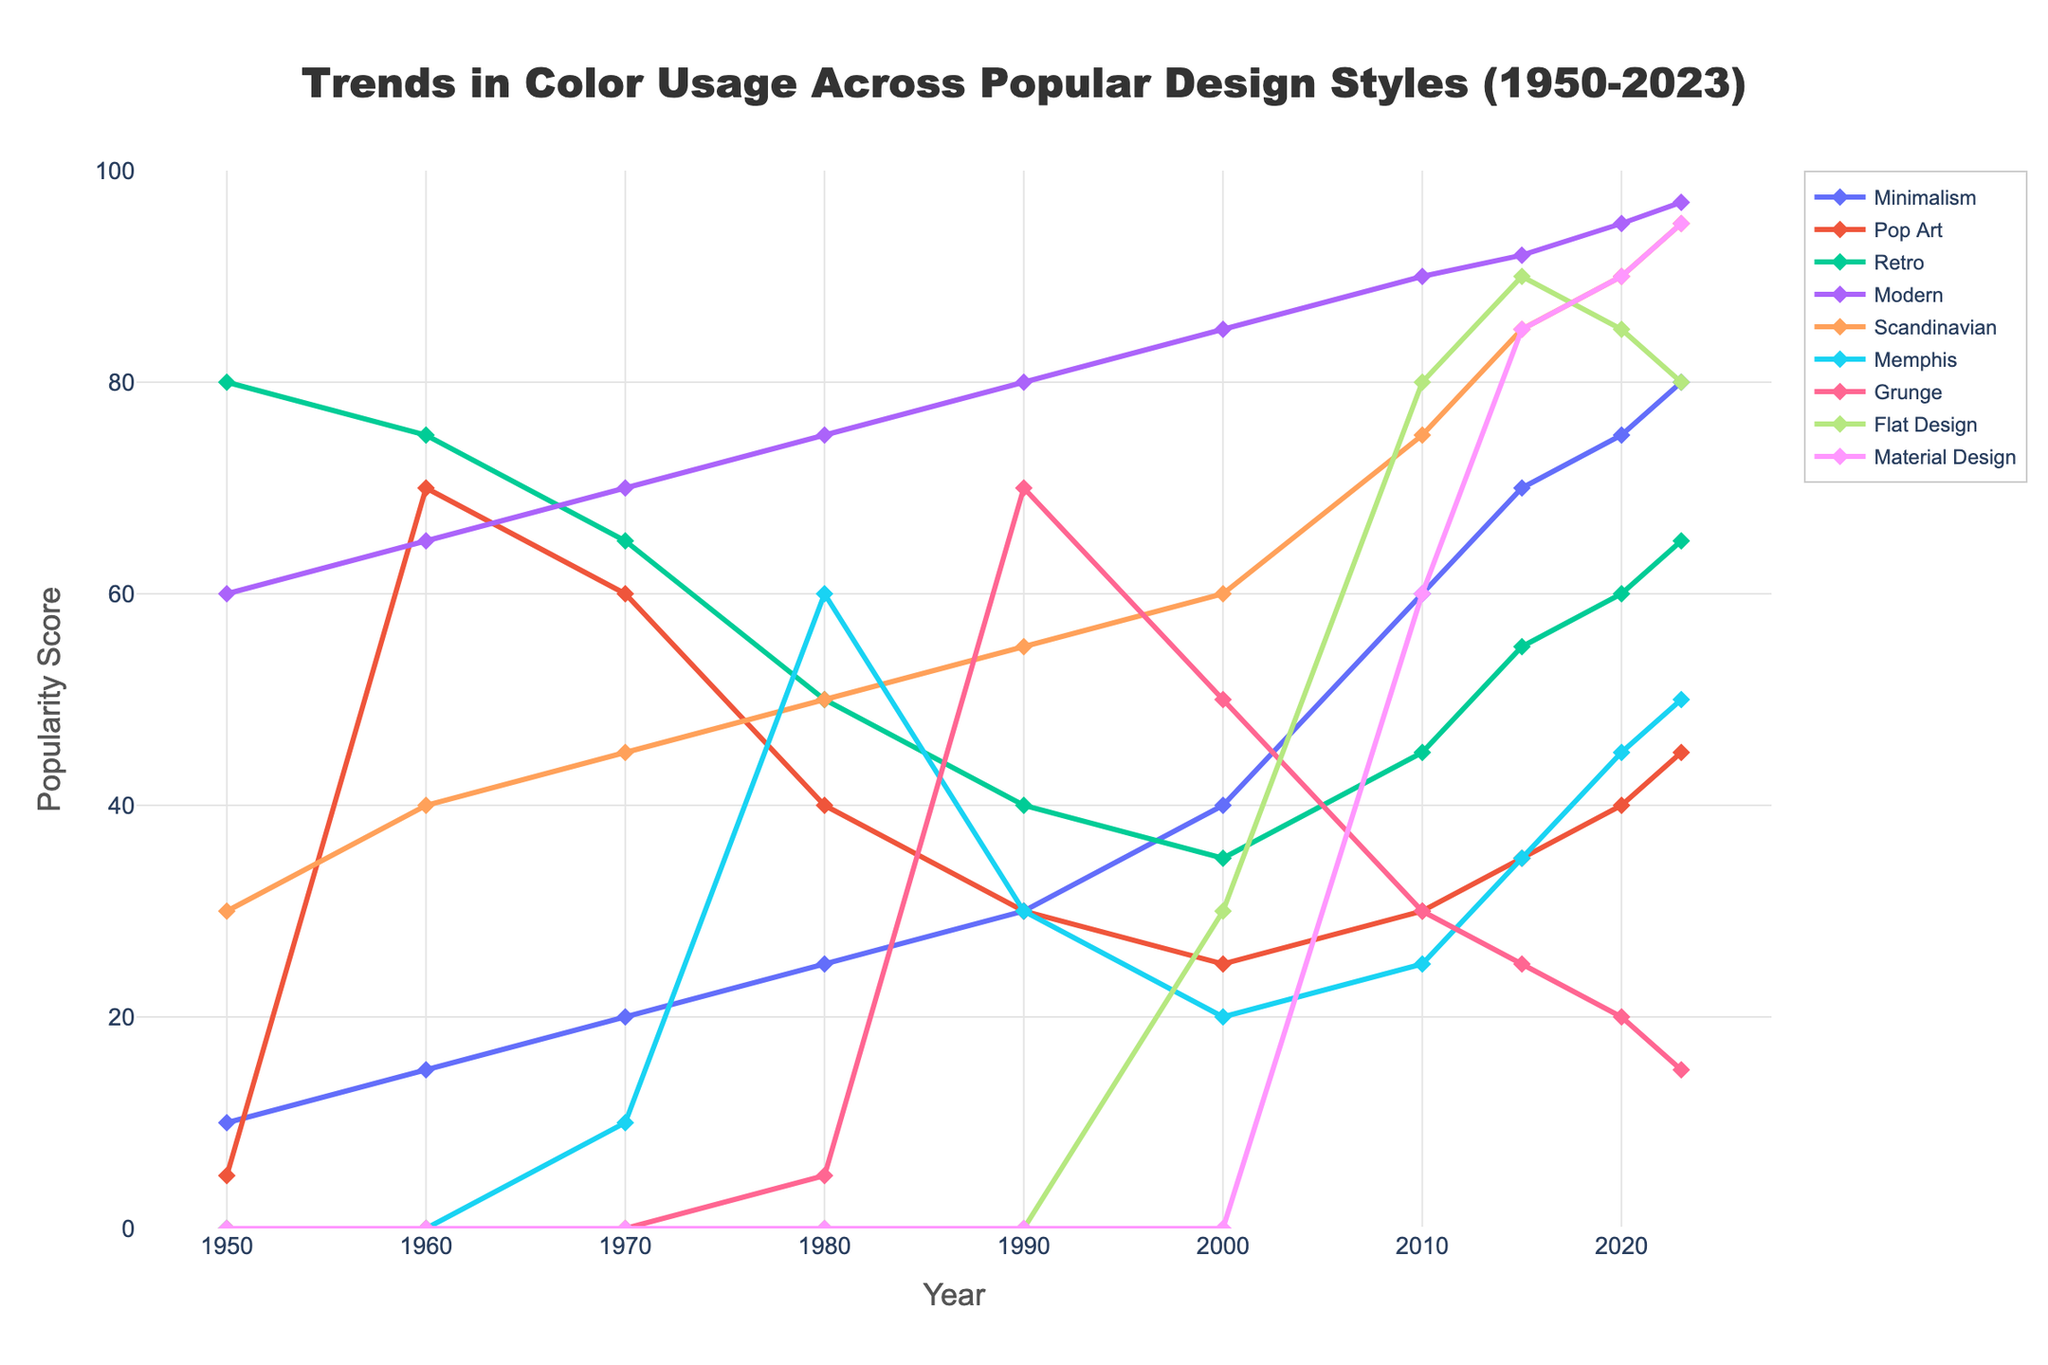What design style had the highest popularity score in 2023? Identify the data point at the furthest right of the timeline for each design style and find the one with the highest value. Scandinavian has a score of 95 in 2023, the highest among all.
Answer: Scandinavian Which design style had the largest increase in popularity between 1950 and 2023? Calculate the difference between the 2023 and 1950 scores for each design style. Minimalism increased from 10 in 1950 to 80 in 2023, an increase of 70, which is the largest among all design styles.
Answer: Minimalism What is the average popularity score of Modern design style from 1950 to 2023? Add up the popularity scores for Modern design style from 1950 to 2023 (60 + 65 + 70 + 75 + 80 + 85 + 90 + 92 + 95 + 97 = 809). Then, divide by the number of years (809 / 10 = 80.9).
Answer: 80.9 Which year saw the introduction of the Memphis design style, and what was its score that year? Look for the first non-zero entry in the Memphis design style series. In 1970, Memphis design style is recorded with a score of 10.
Answer: 1970, 10 How does the popularity of Grunge in 1990 compare to its popularity in 2023? Check the popularity scores for Grunge in both 1990 and 2023. Grunge had a score of 70 in 1990 and a score of 15 in 2023, indicating a decrease.
Answer: Decrease What is the sum of the popularity scores for Minimalism and Flat Design in 2015? Add the values for Minimalism and Flat Design in 2015 (70 + 90 = 160).
Answer: 160 Which design style experienced the most consistent increase in popularity scores from 1950 to 2023? Analyze the trends for each design style, observing how smoothly the scores increase over time. Modern design displays consistent growth throughout the entire period.
Answer: Modern In what year did Material Design reach a popularity score of 90? Check the popularity series to find the year when Material Design reaches a score of 90. In 2020, Material Design has a score of 90.
Answer: 2020 Comparing Minimalism and Pop Art, which had a higher popularity score in 1980 and by how much? Look at the scores of both styles in 1980. Minimalism had a score of 25, and Pop Art had a score of 40. Thus, Pop Art was higher by 15 (40 - 25 = 15).
Answer: Pop Art, 15 What years did Retro design have a score higher than 60? Identify the years where Retro design scores are above 60 in the series: 1950, 1960, and 2020-2023 are the years considered.
Answer: 1950, 1960, 2020, 2021, 2022, 2023 